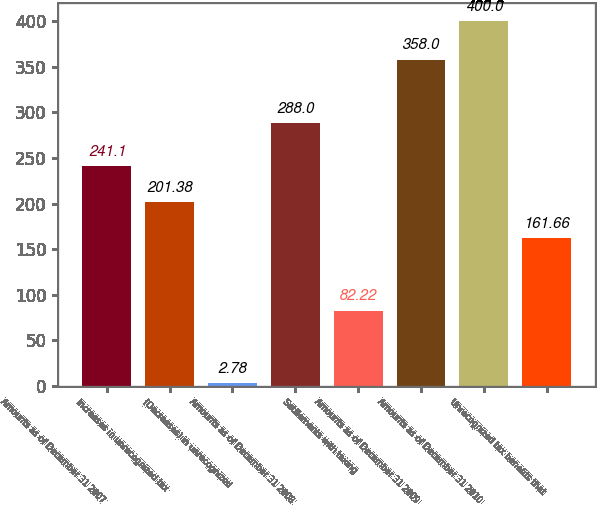<chart> <loc_0><loc_0><loc_500><loc_500><bar_chart><fcel>Amounts as of December 31 2007<fcel>Increases in unrecognized tax<fcel>(Decreases) in unrecognized<fcel>Amounts as of December 31 2008<fcel>Settlements with taxing<fcel>Amounts as of December 31 2009<fcel>Amounts as of December 31 2010<fcel>Unrecognized tax benefits that<nl><fcel>241.1<fcel>201.38<fcel>2.78<fcel>288<fcel>82.22<fcel>358<fcel>400<fcel>161.66<nl></chart> 